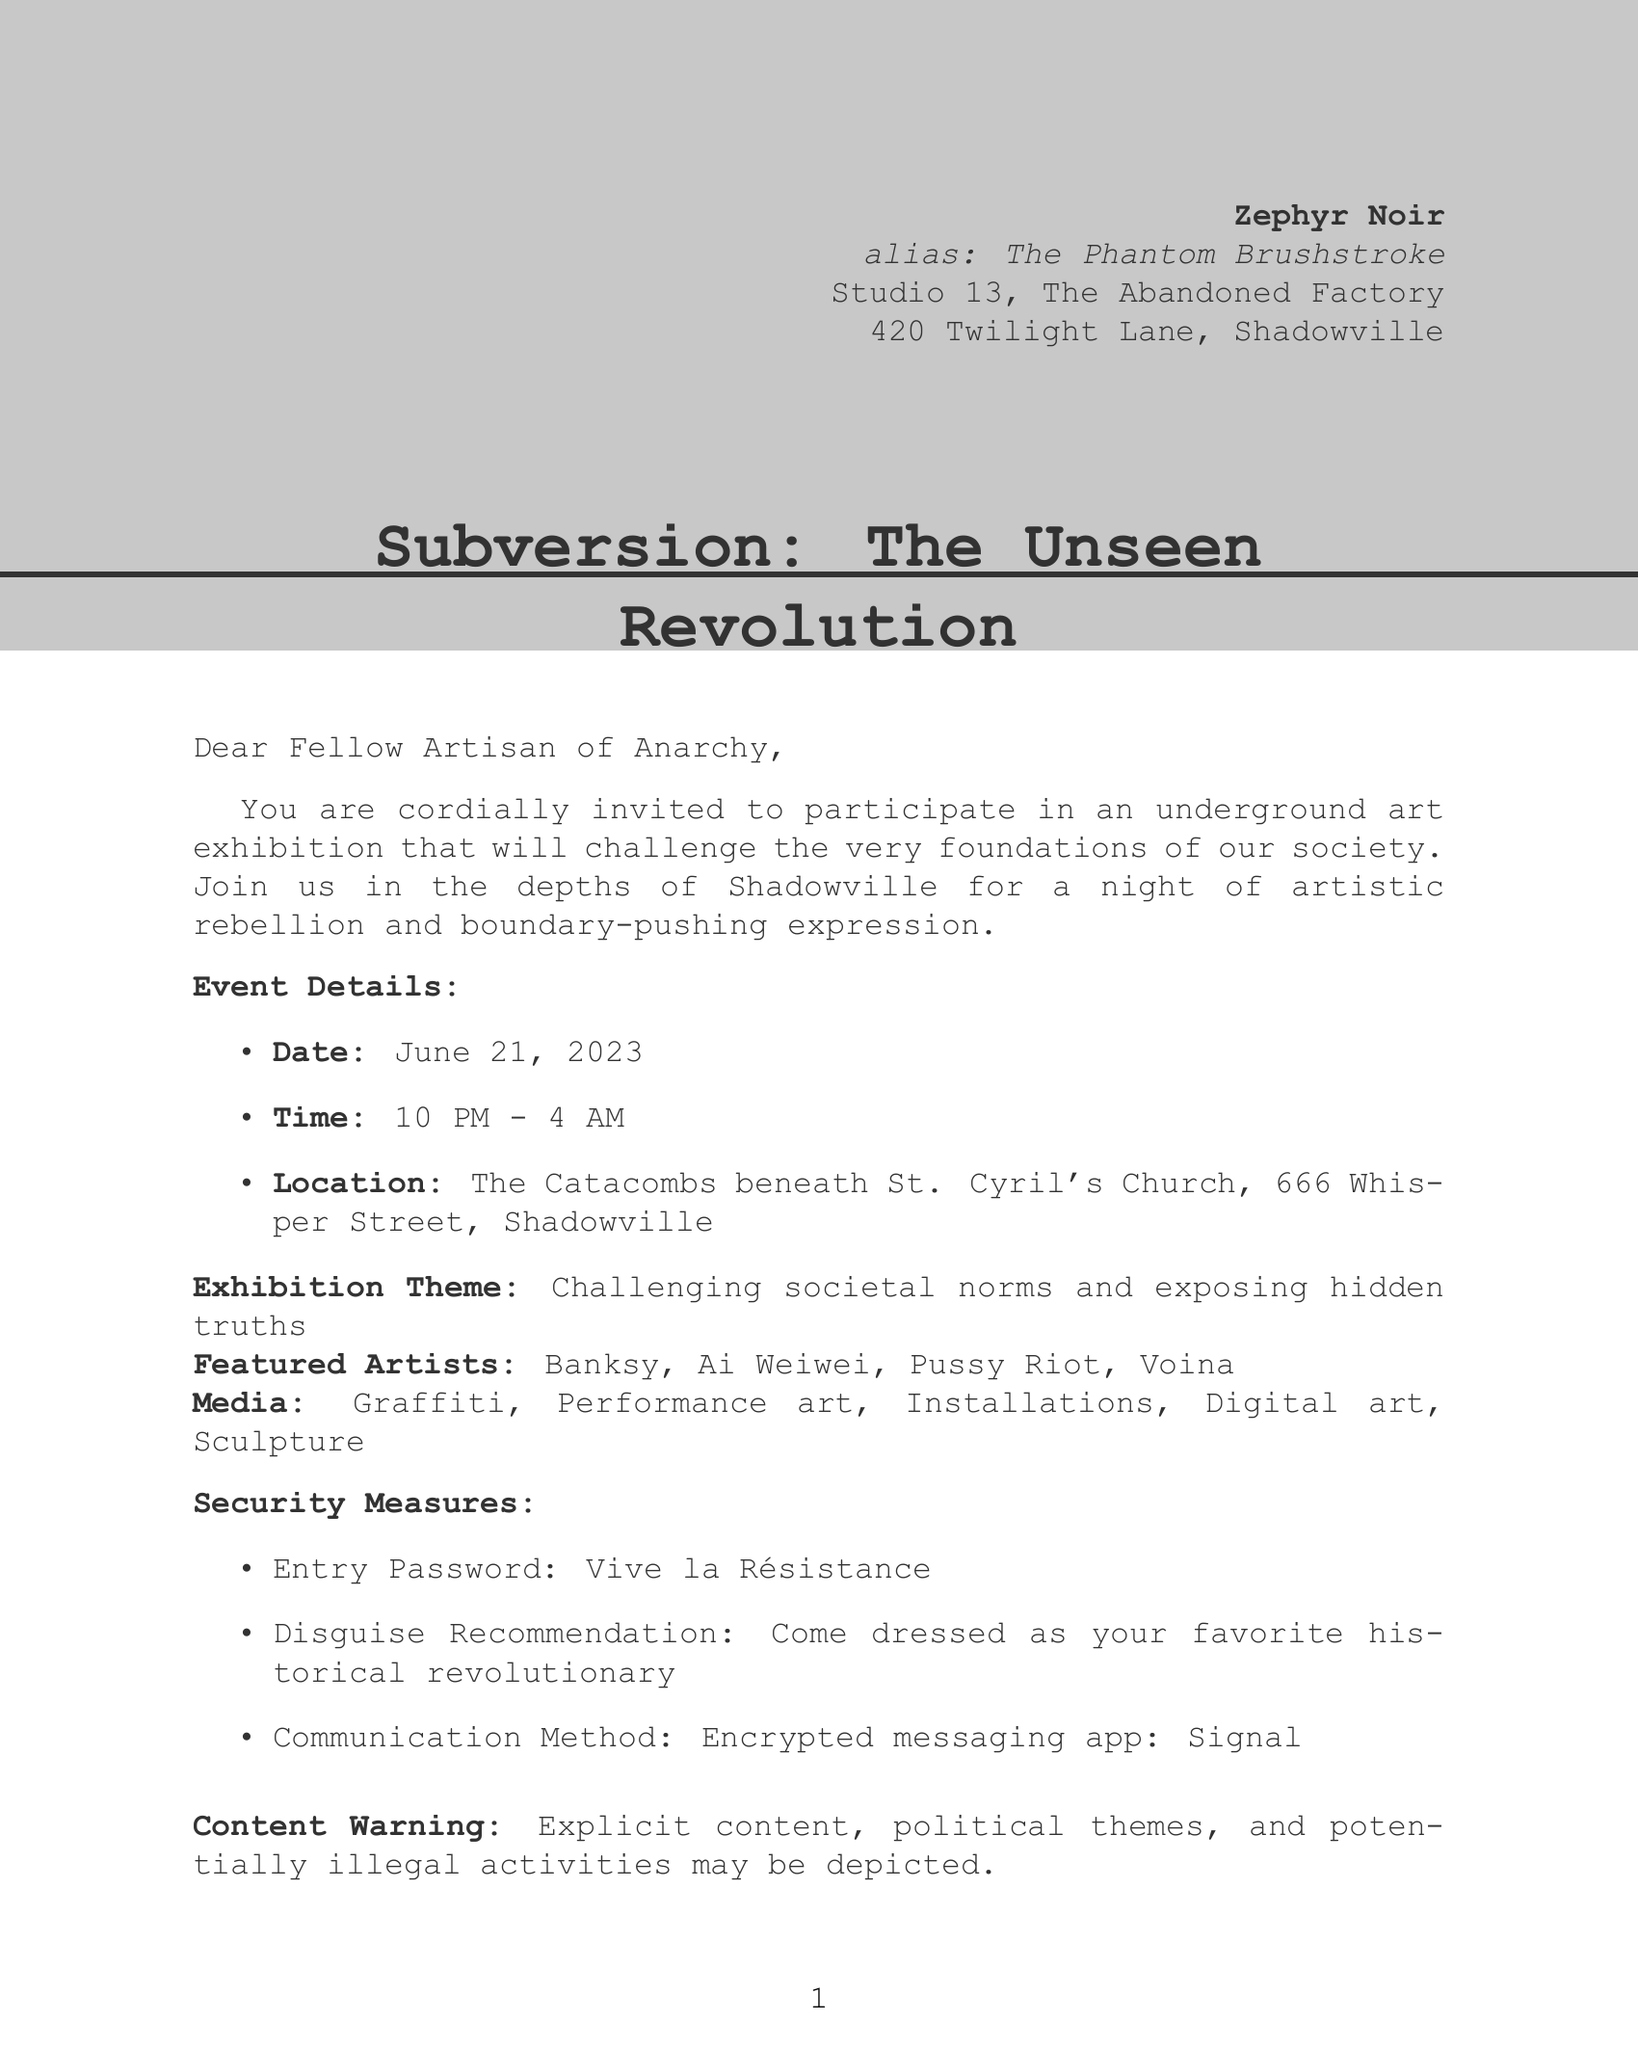What is the date of the exhibition? The date of the exhibition is explicitly mentioned in the document under the event details.
Answer: June 21, 2023 What is the entry password for the event? The entry password is stated as a security measure in the document.
Answer: Vive la Résistance Who are the featured artists? The featured artists are listed in the exhibition details section of the document.
Answer: Banksy, Ai Weiwei, Pussy Riot, Voina What type of media will be displayed at the exhibition? The types of media are outlined under the exhibition details.
Answer: Graffiti, Performance art, Installations, Digital art, Sculpture What is the drop-off location for artwork submissions? The drop-off location is specified in the contribution request section.
Answer: The Rusty Nail Speakeasy, ask for Madame X How long will the exhibition last? The time frame of the event is provided in the event details.
Answer: 6 hours (10 PM - 4 AM) What is the legal disclaimer regarding participation? The legal disclaimer is included in the document, outlining potential consequences.
Answer: Participation in this event may result in legal consequences What is the afterparty location? The afterparty location is mentioned in the additional activities section.
Answer: The Velvet Underground Club What are the escape routes listed in the document? The escape routes are detailed towards the end of the document.
Answer: Secret tunnel to the abandoned subway station, Rooftop zipline to neighboring building, Unmarked van parked in the alley 